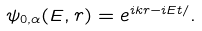Convert formula to latex. <formula><loc_0><loc_0><loc_500><loc_500>\psi _ { 0 , \alpha } ( E , r ) = e ^ { i { k r } - i E t / } .</formula> 